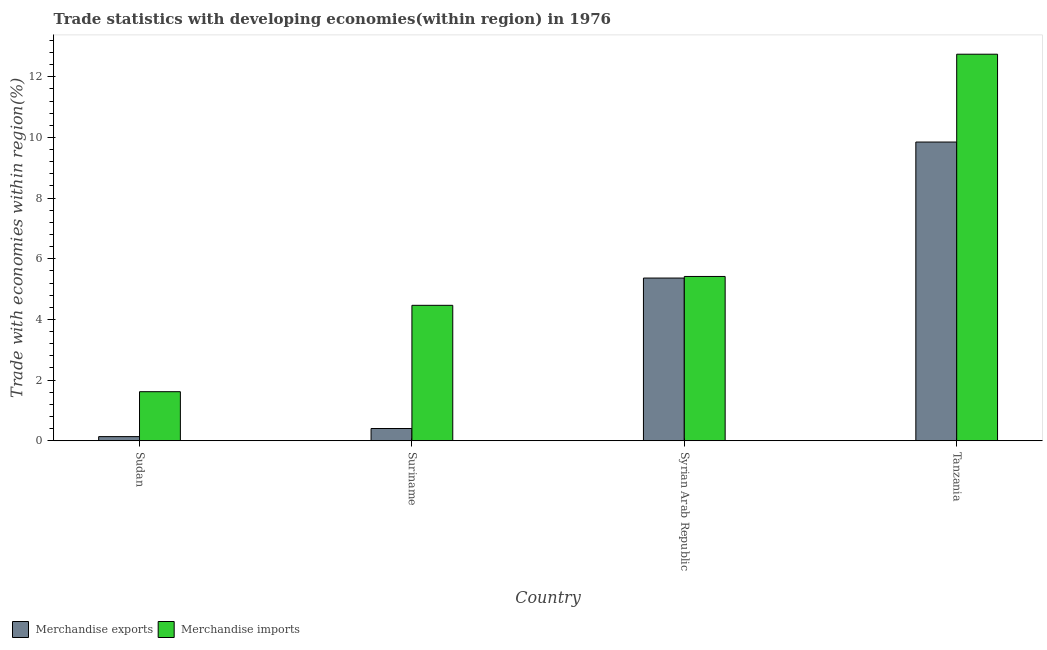How many different coloured bars are there?
Provide a short and direct response. 2. How many groups of bars are there?
Ensure brevity in your answer.  4. Are the number of bars per tick equal to the number of legend labels?
Offer a very short reply. Yes. Are the number of bars on each tick of the X-axis equal?
Provide a short and direct response. Yes. How many bars are there on the 4th tick from the right?
Your response must be concise. 2. What is the label of the 3rd group of bars from the left?
Your answer should be compact. Syrian Arab Republic. In how many cases, is the number of bars for a given country not equal to the number of legend labels?
Your answer should be very brief. 0. What is the merchandise imports in Tanzania?
Your answer should be compact. 12.74. Across all countries, what is the maximum merchandise exports?
Your answer should be very brief. 9.85. Across all countries, what is the minimum merchandise imports?
Provide a succinct answer. 1.62. In which country was the merchandise exports maximum?
Your response must be concise. Tanzania. In which country was the merchandise exports minimum?
Give a very brief answer. Sudan. What is the total merchandise imports in the graph?
Offer a terse response. 24.24. What is the difference between the merchandise exports in Sudan and that in Tanzania?
Your answer should be very brief. -9.71. What is the difference between the merchandise exports in Syrian Arab Republic and the merchandise imports in Tanzania?
Your answer should be compact. -7.38. What is the average merchandise exports per country?
Ensure brevity in your answer.  3.94. What is the difference between the merchandise imports and merchandise exports in Syrian Arab Republic?
Provide a short and direct response. 0.05. In how many countries, is the merchandise exports greater than 2.4 %?
Offer a very short reply. 2. What is the ratio of the merchandise imports in Sudan to that in Syrian Arab Republic?
Your answer should be compact. 0.3. Is the merchandise exports in Sudan less than that in Tanzania?
Give a very brief answer. Yes. Is the difference between the merchandise exports in Suriname and Syrian Arab Republic greater than the difference between the merchandise imports in Suriname and Syrian Arab Republic?
Make the answer very short. No. What is the difference between the highest and the second highest merchandise exports?
Keep it short and to the point. 4.48. What is the difference between the highest and the lowest merchandise exports?
Keep it short and to the point. 9.71. In how many countries, is the merchandise imports greater than the average merchandise imports taken over all countries?
Ensure brevity in your answer.  1. What does the 1st bar from the left in Tanzania represents?
Keep it short and to the point. Merchandise exports. How many bars are there?
Your answer should be very brief. 8. Are the values on the major ticks of Y-axis written in scientific E-notation?
Your answer should be very brief. No. Does the graph contain grids?
Your answer should be compact. No. Where does the legend appear in the graph?
Ensure brevity in your answer.  Bottom left. How many legend labels are there?
Your response must be concise. 2. What is the title of the graph?
Keep it short and to the point. Trade statistics with developing economies(within region) in 1976. Does "Private funds" appear as one of the legend labels in the graph?
Give a very brief answer. No. What is the label or title of the Y-axis?
Your answer should be compact. Trade with economies within region(%). What is the Trade with economies within region(%) of Merchandise exports in Sudan?
Provide a short and direct response. 0.14. What is the Trade with economies within region(%) of Merchandise imports in Sudan?
Ensure brevity in your answer.  1.62. What is the Trade with economies within region(%) of Merchandise exports in Suriname?
Provide a short and direct response. 0.4. What is the Trade with economies within region(%) in Merchandise imports in Suriname?
Offer a terse response. 4.47. What is the Trade with economies within region(%) in Merchandise exports in Syrian Arab Republic?
Provide a succinct answer. 5.36. What is the Trade with economies within region(%) in Merchandise imports in Syrian Arab Republic?
Ensure brevity in your answer.  5.42. What is the Trade with economies within region(%) in Merchandise exports in Tanzania?
Offer a terse response. 9.85. What is the Trade with economies within region(%) of Merchandise imports in Tanzania?
Your answer should be very brief. 12.74. Across all countries, what is the maximum Trade with economies within region(%) of Merchandise exports?
Provide a short and direct response. 9.85. Across all countries, what is the maximum Trade with economies within region(%) in Merchandise imports?
Make the answer very short. 12.74. Across all countries, what is the minimum Trade with economies within region(%) in Merchandise exports?
Your answer should be very brief. 0.14. Across all countries, what is the minimum Trade with economies within region(%) of Merchandise imports?
Your response must be concise. 1.62. What is the total Trade with economies within region(%) in Merchandise exports in the graph?
Provide a short and direct response. 15.75. What is the total Trade with economies within region(%) of Merchandise imports in the graph?
Keep it short and to the point. 24.24. What is the difference between the Trade with economies within region(%) in Merchandise exports in Sudan and that in Suriname?
Provide a succinct answer. -0.27. What is the difference between the Trade with economies within region(%) of Merchandise imports in Sudan and that in Suriname?
Ensure brevity in your answer.  -2.85. What is the difference between the Trade with economies within region(%) in Merchandise exports in Sudan and that in Syrian Arab Republic?
Your response must be concise. -5.23. What is the difference between the Trade with economies within region(%) in Merchandise imports in Sudan and that in Syrian Arab Republic?
Make the answer very short. -3.8. What is the difference between the Trade with economies within region(%) of Merchandise exports in Sudan and that in Tanzania?
Offer a terse response. -9.71. What is the difference between the Trade with economies within region(%) of Merchandise imports in Sudan and that in Tanzania?
Your response must be concise. -11.12. What is the difference between the Trade with economies within region(%) in Merchandise exports in Suriname and that in Syrian Arab Republic?
Keep it short and to the point. -4.96. What is the difference between the Trade with economies within region(%) of Merchandise imports in Suriname and that in Syrian Arab Republic?
Make the answer very short. -0.95. What is the difference between the Trade with economies within region(%) of Merchandise exports in Suriname and that in Tanzania?
Your answer should be compact. -9.44. What is the difference between the Trade with economies within region(%) of Merchandise imports in Suriname and that in Tanzania?
Provide a succinct answer. -8.28. What is the difference between the Trade with economies within region(%) in Merchandise exports in Syrian Arab Republic and that in Tanzania?
Give a very brief answer. -4.48. What is the difference between the Trade with economies within region(%) of Merchandise imports in Syrian Arab Republic and that in Tanzania?
Offer a terse response. -7.33. What is the difference between the Trade with economies within region(%) of Merchandise exports in Sudan and the Trade with economies within region(%) of Merchandise imports in Suriname?
Your response must be concise. -4.33. What is the difference between the Trade with economies within region(%) in Merchandise exports in Sudan and the Trade with economies within region(%) in Merchandise imports in Syrian Arab Republic?
Keep it short and to the point. -5.28. What is the difference between the Trade with economies within region(%) of Merchandise exports in Sudan and the Trade with economies within region(%) of Merchandise imports in Tanzania?
Your response must be concise. -12.61. What is the difference between the Trade with economies within region(%) in Merchandise exports in Suriname and the Trade with economies within region(%) in Merchandise imports in Syrian Arab Republic?
Provide a succinct answer. -5.01. What is the difference between the Trade with economies within region(%) of Merchandise exports in Suriname and the Trade with economies within region(%) of Merchandise imports in Tanzania?
Offer a terse response. -12.34. What is the difference between the Trade with economies within region(%) in Merchandise exports in Syrian Arab Republic and the Trade with economies within region(%) in Merchandise imports in Tanzania?
Provide a short and direct response. -7.38. What is the average Trade with economies within region(%) in Merchandise exports per country?
Give a very brief answer. 3.94. What is the average Trade with economies within region(%) in Merchandise imports per country?
Your response must be concise. 6.06. What is the difference between the Trade with economies within region(%) of Merchandise exports and Trade with economies within region(%) of Merchandise imports in Sudan?
Your response must be concise. -1.48. What is the difference between the Trade with economies within region(%) of Merchandise exports and Trade with economies within region(%) of Merchandise imports in Suriname?
Your response must be concise. -4.06. What is the difference between the Trade with economies within region(%) of Merchandise exports and Trade with economies within region(%) of Merchandise imports in Syrian Arab Republic?
Your answer should be compact. -0.05. What is the difference between the Trade with economies within region(%) in Merchandise exports and Trade with economies within region(%) in Merchandise imports in Tanzania?
Your response must be concise. -2.9. What is the ratio of the Trade with economies within region(%) in Merchandise exports in Sudan to that in Suriname?
Offer a very short reply. 0.34. What is the ratio of the Trade with economies within region(%) of Merchandise imports in Sudan to that in Suriname?
Offer a terse response. 0.36. What is the ratio of the Trade with economies within region(%) in Merchandise exports in Sudan to that in Syrian Arab Republic?
Give a very brief answer. 0.03. What is the ratio of the Trade with economies within region(%) of Merchandise imports in Sudan to that in Syrian Arab Republic?
Your answer should be very brief. 0.3. What is the ratio of the Trade with economies within region(%) in Merchandise exports in Sudan to that in Tanzania?
Ensure brevity in your answer.  0.01. What is the ratio of the Trade with economies within region(%) of Merchandise imports in Sudan to that in Tanzania?
Keep it short and to the point. 0.13. What is the ratio of the Trade with economies within region(%) in Merchandise exports in Suriname to that in Syrian Arab Republic?
Offer a very short reply. 0.08. What is the ratio of the Trade with economies within region(%) in Merchandise imports in Suriname to that in Syrian Arab Republic?
Offer a very short reply. 0.82. What is the ratio of the Trade with economies within region(%) in Merchandise exports in Suriname to that in Tanzania?
Make the answer very short. 0.04. What is the ratio of the Trade with economies within region(%) of Merchandise imports in Suriname to that in Tanzania?
Ensure brevity in your answer.  0.35. What is the ratio of the Trade with economies within region(%) of Merchandise exports in Syrian Arab Republic to that in Tanzania?
Your response must be concise. 0.54. What is the ratio of the Trade with economies within region(%) in Merchandise imports in Syrian Arab Republic to that in Tanzania?
Provide a succinct answer. 0.43. What is the difference between the highest and the second highest Trade with economies within region(%) of Merchandise exports?
Your response must be concise. 4.48. What is the difference between the highest and the second highest Trade with economies within region(%) of Merchandise imports?
Make the answer very short. 7.33. What is the difference between the highest and the lowest Trade with economies within region(%) in Merchandise exports?
Your answer should be very brief. 9.71. What is the difference between the highest and the lowest Trade with economies within region(%) in Merchandise imports?
Offer a terse response. 11.12. 